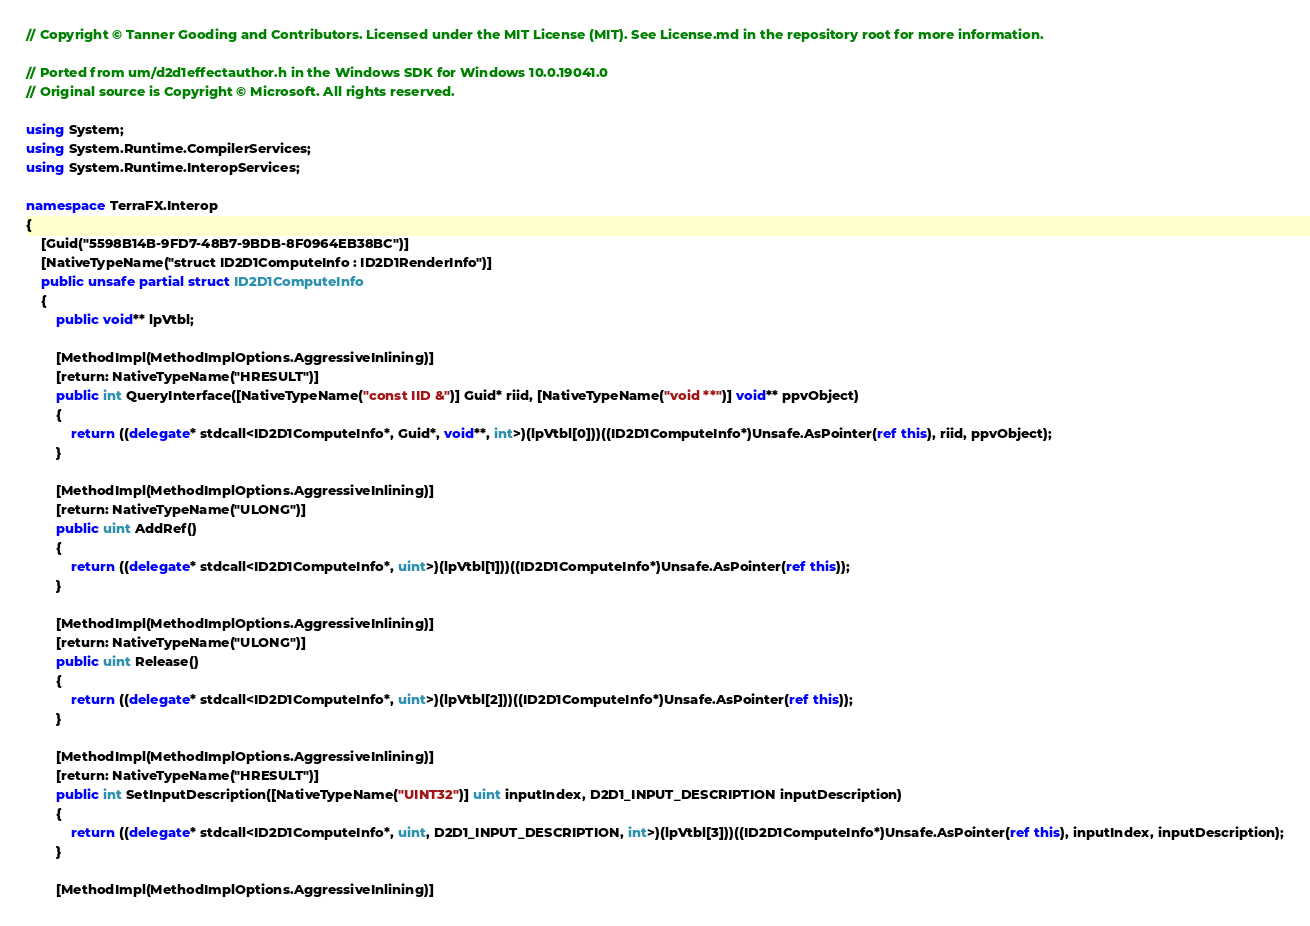<code> <loc_0><loc_0><loc_500><loc_500><_C#_>// Copyright © Tanner Gooding and Contributors. Licensed under the MIT License (MIT). See License.md in the repository root for more information.

// Ported from um/d2d1effectauthor.h in the Windows SDK for Windows 10.0.19041.0
// Original source is Copyright © Microsoft. All rights reserved.

using System;
using System.Runtime.CompilerServices;
using System.Runtime.InteropServices;

namespace TerraFX.Interop
{
    [Guid("5598B14B-9FD7-48B7-9BDB-8F0964EB38BC")]
    [NativeTypeName("struct ID2D1ComputeInfo : ID2D1RenderInfo")]
    public unsafe partial struct ID2D1ComputeInfo
    {
        public void** lpVtbl;

        [MethodImpl(MethodImplOptions.AggressiveInlining)]
        [return: NativeTypeName("HRESULT")]
        public int QueryInterface([NativeTypeName("const IID &")] Guid* riid, [NativeTypeName("void **")] void** ppvObject)
        {
            return ((delegate* stdcall<ID2D1ComputeInfo*, Guid*, void**, int>)(lpVtbl[0]))((ID2D1ComputeInfo*)Unsafe.AsPointer(ref this), riid, ppvObject);
        }

        [MethodImpl(MethodImplOptions.AggressiveInlining)]
        [return: NativeTypeName("ULONG")]
        public uint AddRef()
        {
            return ((delegate* stdcall<ID2D1ComputeInfo*, uint>)(lpVtbl[1]))((ID2D1ComputeInfo*)Unsafe.AsPointer(ref this));
        }

        [MethodImpl(MethodImplOptions.AggressiveInlining)]
        [return: NativeTypeName("ULONG")]
        public uint Release()
        {
            return ((delegate* stdcall<ID2D1ComputeInfo*, uint>)(lpVtbl[2]))((ID2D1ComputeInfo*)Unsafe.AsPointer(ref this));
        }

        [MethodImpl(MethodImplOptions.AggressiveInlining)]
        [return: NativeTypeName("HRESULT")]
        public int SetInputDescription([NativeTypeName("UINT32")] uint inputIndex, D2D1_INPUT_DESCRIPTION inputDescription)
        {
            return ((delegate* stdcall<ID2D1ComputeInfo*, uint, D2D1_INPUT_DESCRIPTION, int>)(lpVtbl[3]))((ID2D1ComputeInfo*)Unsafe.AsPointer(ref this), inputIndex, inputDescription);
        }

        [MethodImpl(MethodImplOptions.AggressiveInlining)]</code> 